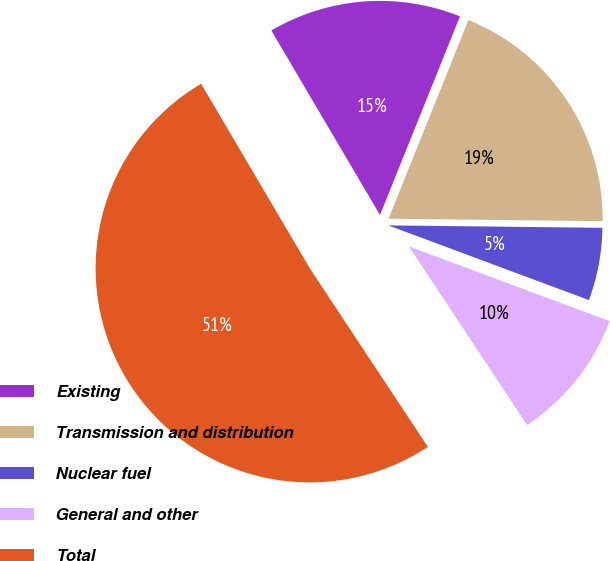<chart> <loc_0><loc_0><loc_500><loc_500><pie_chart><fcel>Existing<fcel>Transmission and distribution<fcel>Nuclear fuel<fcel>General and other<fcel>Total<nl><fcel>14.56%<fcel>19.09%<fcel>5.49%<fcel>10.03%<fcel>50.83%<nl></chart> 